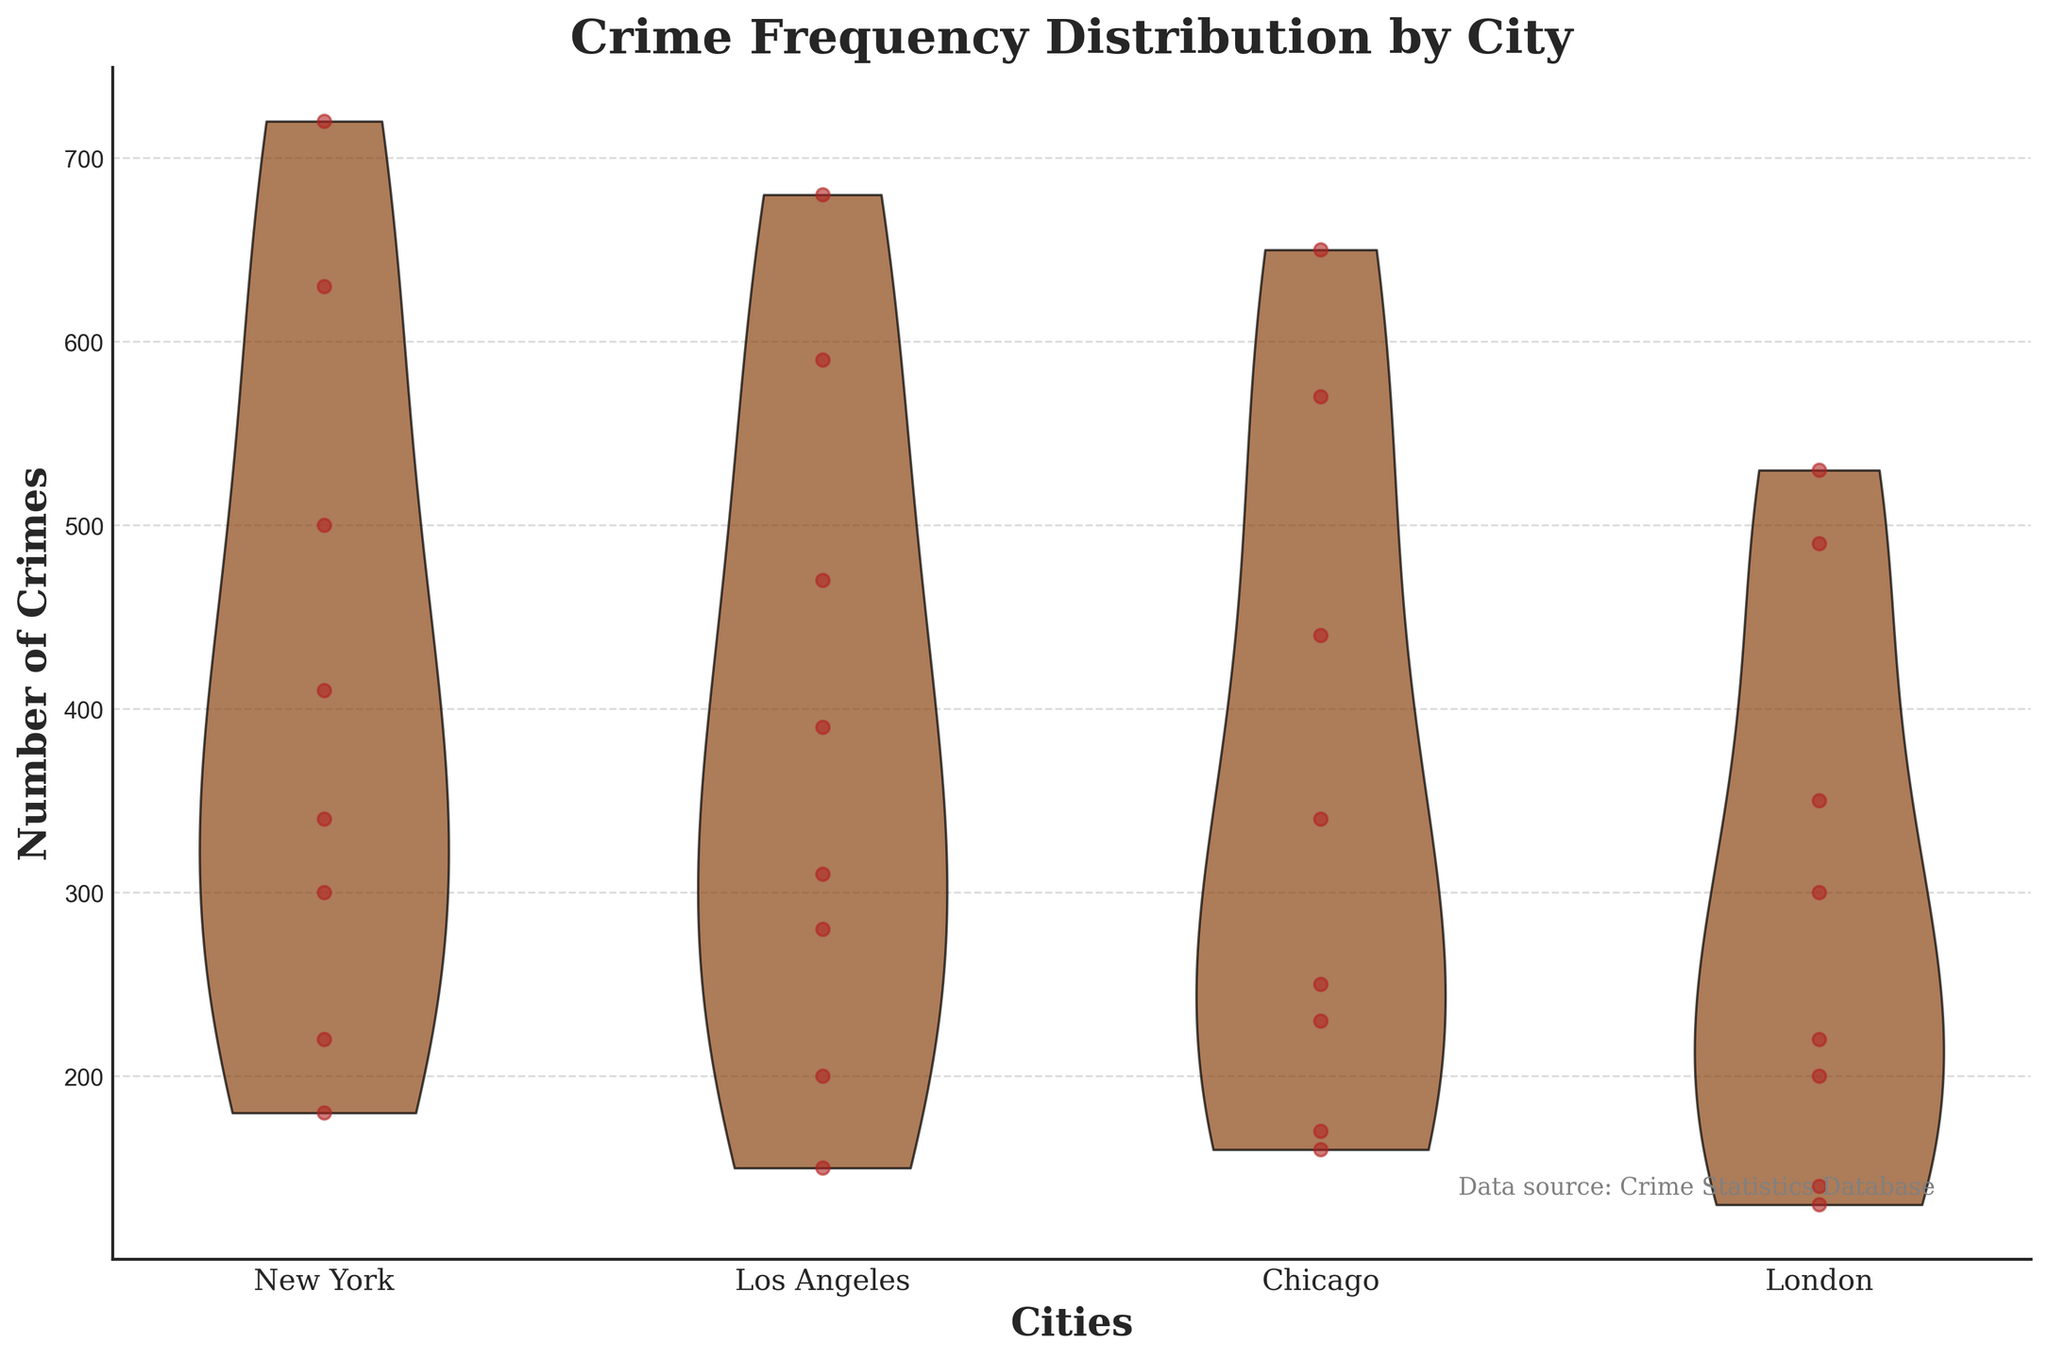What does the title of the figure say? The title of the figure is clearly provided at the top. It reads "Crime Frequency Distribution by City," which indicates the focus of the plot is on how the frequency of crimes varies across different cities.
Answer: Crime Frequency Distribution by City Which city shows the highest peak in the number of crimes? By examining the violin plot, the city with the highest density and a wider range in crime numbers will typically appear more pronounced. For this figure, New York shows the most prominent peak.
Answer: New York What is the color used for the bodies of the violins in the chart? The bodies of the violin plots are filled with a specific color to make them distinguishable. In this figure, the bodies of the violins are primarily colored in brown with black edges.
Answer: Brown Which city appears to have the lowest overall crime frequency? To determine the city with the lowest overall crime frequency, we need to look for the violin with the lowest density and fewer spread points around the y-axis. London generally shows lower values compared to others.
Answer: London How are crime frequencies distributed for Los Angeles throughout the day? Examining the scatter points along the y-axis for Los Angeles can provide this insight. The distribution shows a range from lower values at night and early morning hours to higher frequencies during the late afternoon and night.
Answer: Crime frequencies are lower during the early morning hours and higher in the late afternoon and night Which city shows a higher concentration of crimes at night (21:00-00:00)? By inspecting the scatter points within each violin plot, especially focusing on the density towards higher y-axis values, New York and Los Angeles have a higher concentration of scatter points around that time period.
Answer: New York and Los Angeles Compare the crime frequencies between New York and Chicago. Which city has more variability in crime numbers? Studying the spread and density of points in the violin plots for New York and Chicago helps in comparing their variability. New York exhibits a broader spread indicating more variability compared to Chicago.
Answer: New York What are the names of the cities included in this plot? At a glance, we can identify the unique cities from the x-axis labels, which are given in the plot. These cities are New York, Los Angeles, Chicago, and London.
Answer: New York, Los Angeles, Chicago, London How is the visual grid structured in the background of the chart? Observing the grid structure in the chart, it is apparent that there are horizontal grid lines used to help gauge the values on the y-axis. These grid lines extend across the width of the plot.
Answer: Horizontal grid lines Which city has a more pronounced evening (18:00-21:00) crime spike compared to others? By closely examining the density and concentration of points in the violin plots for each city during the evening hours (18:00-21:00), it is evident that New York has the most pronounced spike.
Answer: New York 